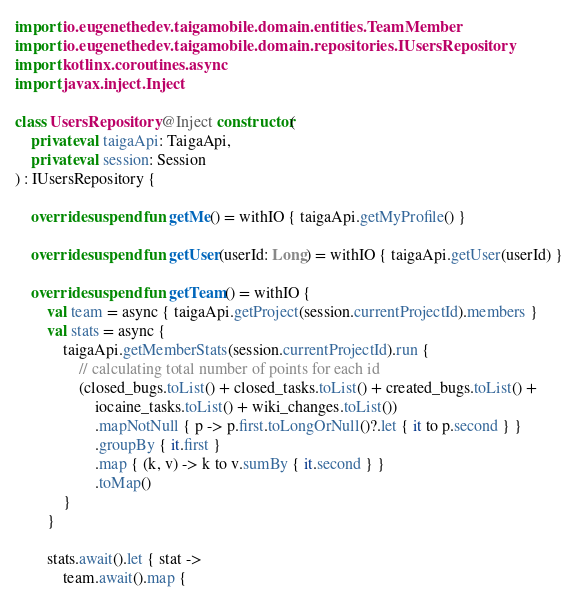Convert code to text. <code><loc_0><loc_0><loc_500><loc_500><_Kotlin_>import io.eugenethedev.taigamobile.domain.entities.TeamMember
import io.eugenethedev.taigamobile.domain.repositories.IUsersRepository
import kotlinx.coroutines.async
import javax.inject.Inject

class UsersRepository @Inject constructor(
    private val taigaApi: TaigaApi,
    private val session: Session
) : IUsersRepository {

    override suspend fun getMe() = withIO { taigaApi.getMyProfile() }

    override suspend fun getUser(userId: Long) = withIO { taigaApi.getUser(userId) }

    override suspend fun getTeam() = withIO {
        val team = async { taigaApi.getProject(session.currentProjectId).members }
        val stats = async {
            taigaApi.getMemberStats(session.currentProjectId).run {
                // calculating total number of points for each id
                (closed_bugs.toList() + closed_tasks.toList() + created_bugs.toList() +
                    iocaine_tasks.toList() + wiki_changes.toList())
                    .mapNotNull { p -> p.first.toLongOrNull()?.let { it to p.second } }
                    .groupBy { it.first }
                    .map { (k, v) -> k to v.sumBy { it.second } }
                    .toMap()
            }
        }

        stats.await().let { stat ->
            team.await().map {</code> 